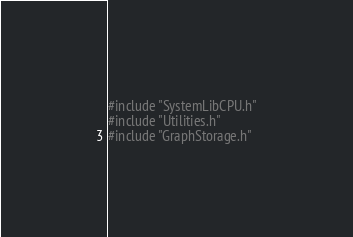<code> <loc_0><loc_0><loc_500><loc_500><_Cuda_>#include "SystemLibCPU.h"
#include "Utilities.h"
#include "GraphStorage.h"

</code> 